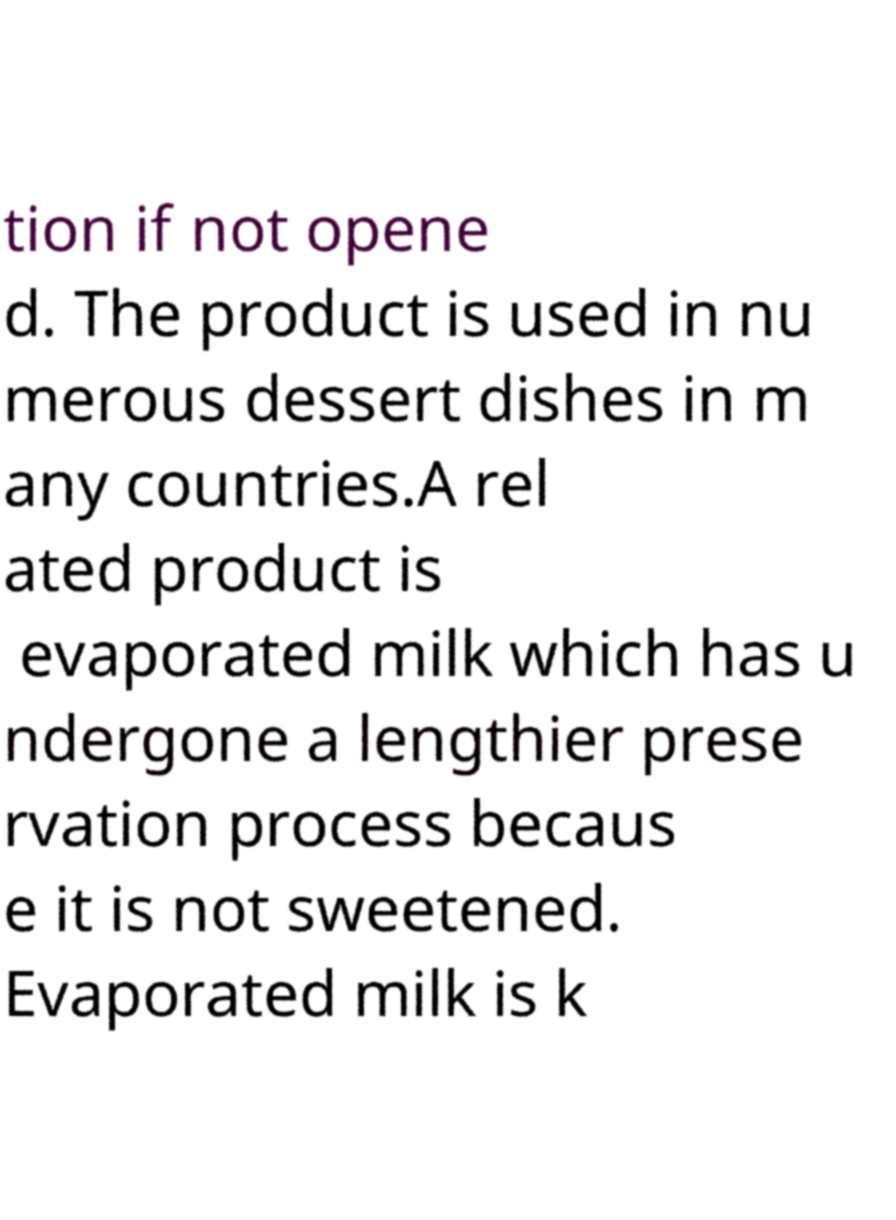Can you accurately transcribe the text from the provided image for me? tion if not opene d. The product is used in nu merous dessert dishes in m any countries.A rel ated product is evaporated milk which has u ndergone a lengthier prese rvation process becaus e it is not sweetened. Evaporated milk is k 